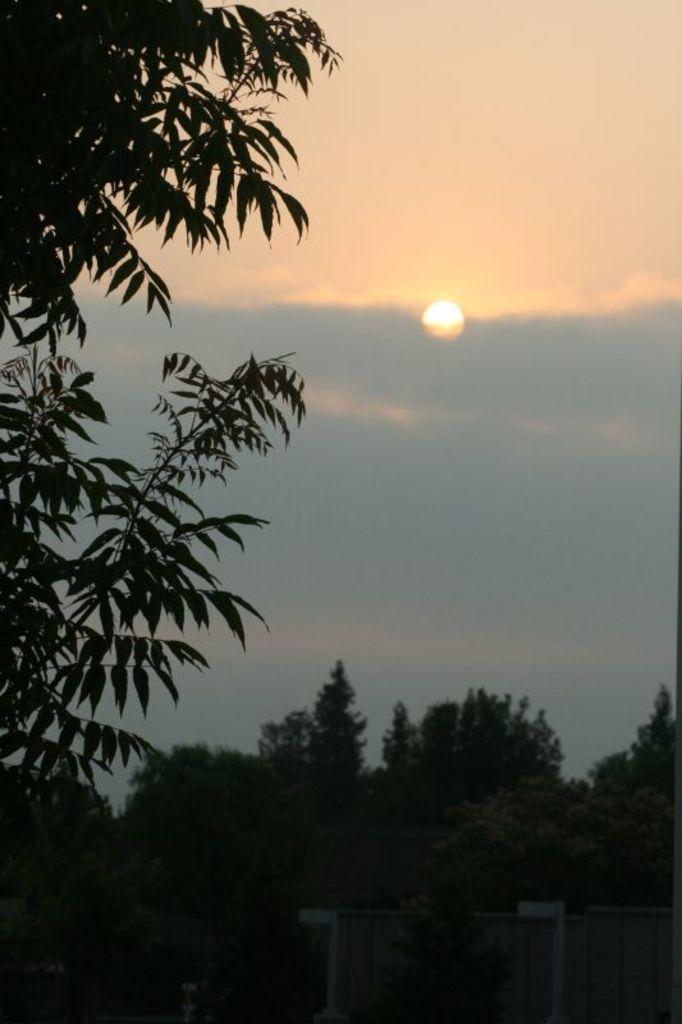Could you give a brief overview of what you see in this image? In this image I can see trees, background I can see sky in blue and white color. 